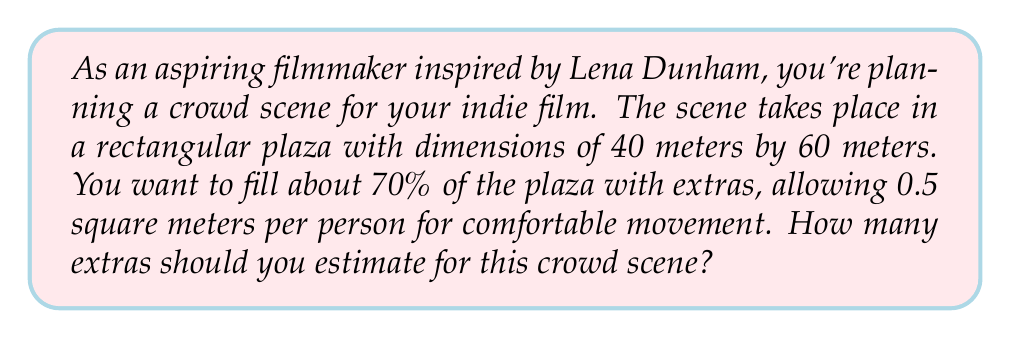What is the answer to this math problem? To solve this problem, we'll follow these steps:

1. Calculate the total area of the plaza:
   $$A_{total} = length \times width = 40 \text{ m} \times 60 \text{ m} = 2400 \text{ m}^2$$

2. Calculate 70% of the total area (the area to be filled with extras):
   $$A_{filled} = 70\% \times A_{total} = 0.7 \times 2400 \text{ m}^2 = 1680 \text{ m}^2$$

3. Calculate the number of extras needed:
   $$\text{Number of extras} = \frac{A_{filled}}{\text{Area per person}}$$
   
   $$\text{Number of extras} = \frac{1680 \text{ m}^2}{0.5 \text{ m}^2/\text{person}} = 3360 \text{ people}$$

4. Round to a reasonable number for estimation:
   We can round this to 3400 extras for easier logistics.
Answer: Estimate approximately 3400 extras for the crowd scene. 